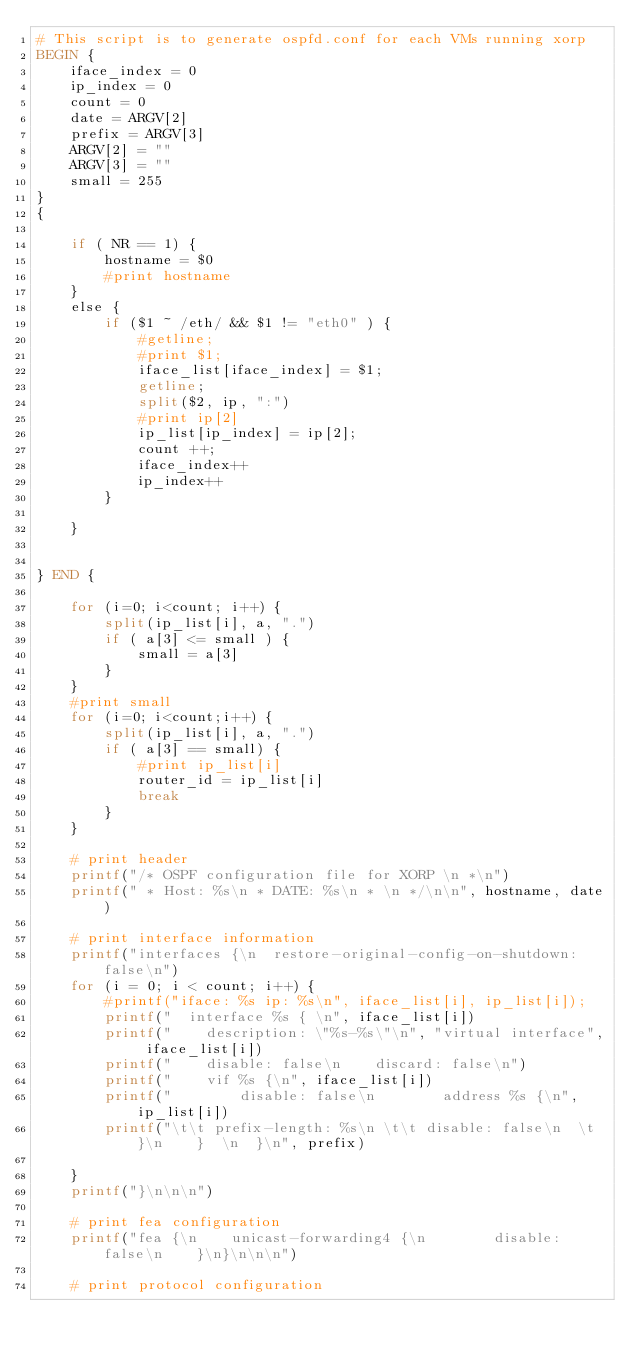<code> <loc_0><loc_0><loc_500><loc_500><_Awk_># This script is to generate ospfd.conf for each VMs running xorp
BEGIN {
	iface_index = 0
	ip_index = 0
	count = 0
	date = ARGV[2]
	prefix = ARGV[3]
	ARGV[2] = ""
	ARGV[3] = ""
	small = 255
}
{

	if ( NR == 1) {
		hostname = $0
		#print hostname
	}
	else {
		if ($1 ~ /eth/ && $1 != "eth0" ) {
			#getline; 
			#print $1;
			iface_list[iface_index] = $1;
			getline;
			split($2, ip, ":")
			#print ip[2]
			ip_list[ip_index] = ip[2];
			count ++;
			iface_index++
			ip_index++
		}

	}
    
	
} END {

    for (i=0; i<count; i++) {
		split(ip_list[i], a, ".")
		if ( a[3] <= small ) {
			small = a[3]
		}
	}
	#print small
	for (i=0; i<count;i++) {
		split(ip_list[i], a, ".")
		if ( a[3] == small) {
			#print ip_list[i]
			router_id = ip_list[i]
			break
		}
	}

	# print header
	printf("/* OSPF configuration file for XORP \n *\n")
    printf(" * Host: %s\n * DATE: %s\n * \n */\n\n", hostname, date)
	
	# print interface information
	printf("interfaces {\n  restore-original-config-on-shutdown: false\n")
	for (i = 0; i < count; i++) {
		#printf("iface: %s ip: %s\n", iface_list[i], ip_list[i]);
		printf("  interface %s { \n", iface_list[i])
		printf("    description: \"%s-%s\"\n", "virtual interface", iface_list[i])
		printf("    disable: false\n    discard: false\n")
		printf("    vif %s {\n", iface_list[i])
		printf("        disable: false\n        address %s {\n", ip_list[i])
		printf("\t\t prefix-length: %s\n \t\t disable: false\n  \t}\n    }  \n  }\n", prefix)		

	}
	printf("}\n\n\n")

	# print fea configuration
	printf("fea {\n    unicast-forwarding4 {\n        disable: false\n    }\n}\n\n\n")

	# print protocol configuration</code> 